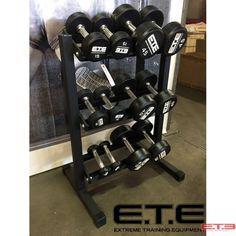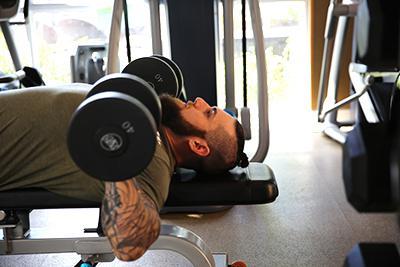The first image is the image on the left, the second image is the image on the right. Considering the images on both sides, is "There is a human near dumbells in one of the images." valid? Answer yes or no. Yes. 